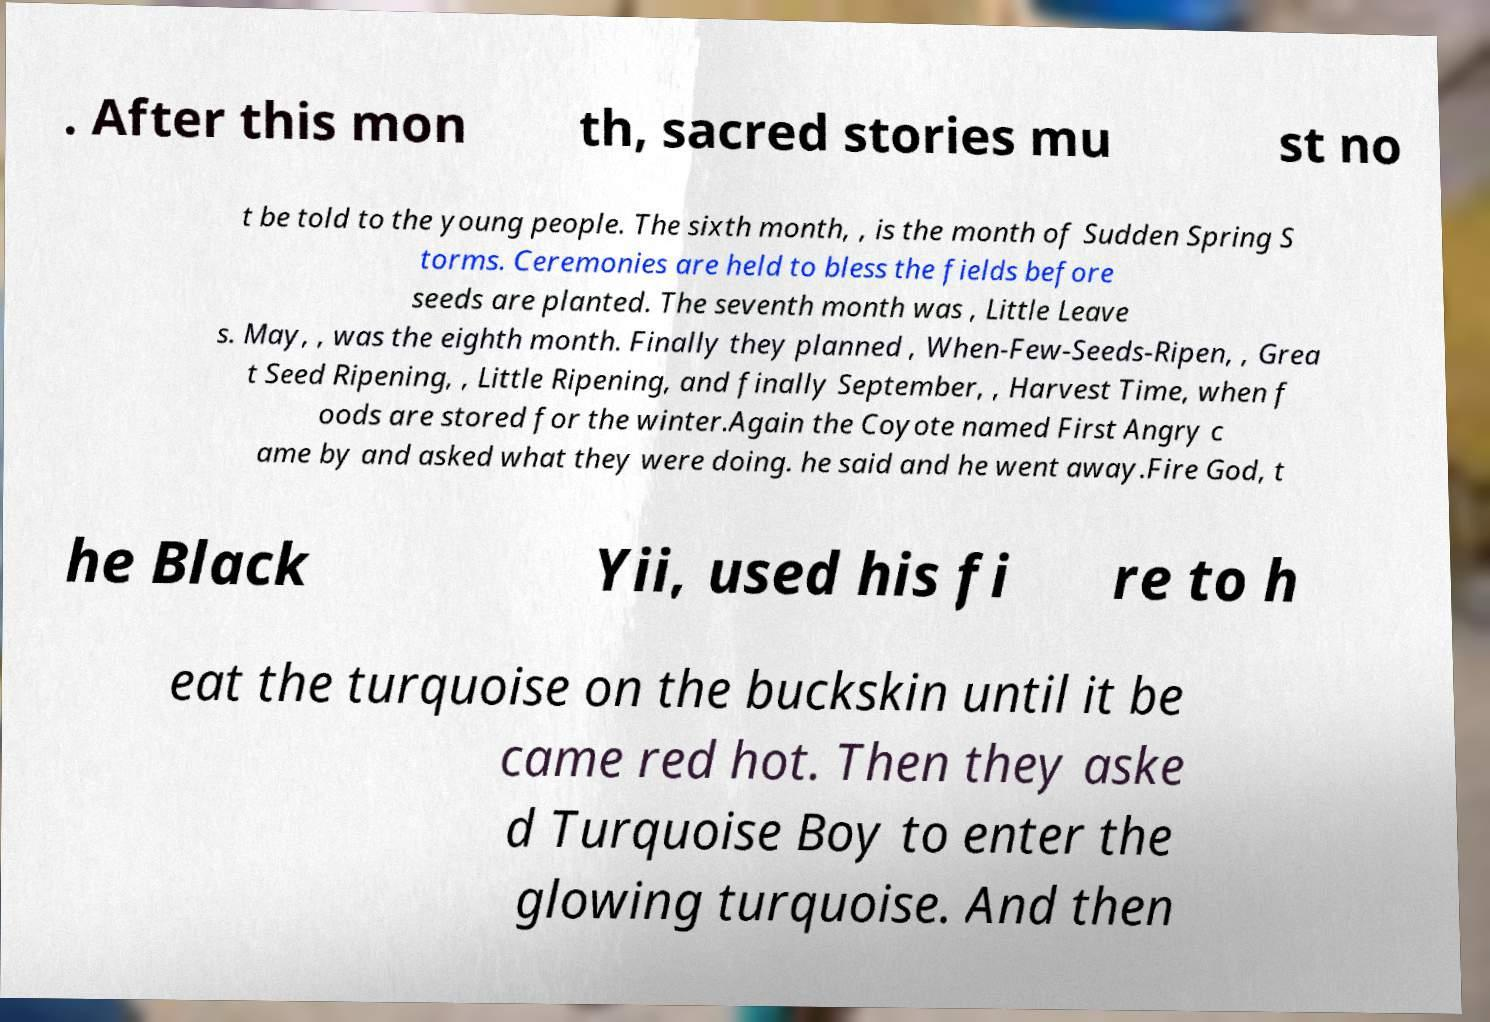Could you extract and type out the text from this image? . After this mon th, sacred stories mu st no t be told to the young people. The sixth month, , is the month of Sudden Spring S torms. Ceremonies are held to bless the fields before seeds are planted. The seventh month was , Little Leave s. May, , was the eighth month. Finally they planned , When-Few-Seeds-Ripen, , Grea t Seed Ripening, , Little Ripening, and finally September, , Harvest Time, when f oods are stored for the winter.Again the Coyote named First Angry c ame by and asked what they were doing. he said and he went away.Fire God, t he Black Yii, used his fi re to h eat the turquoise on the buckskin until it be came red hot. Then they aske d Turquoise Boy to enter the glowing turquoise. And then 